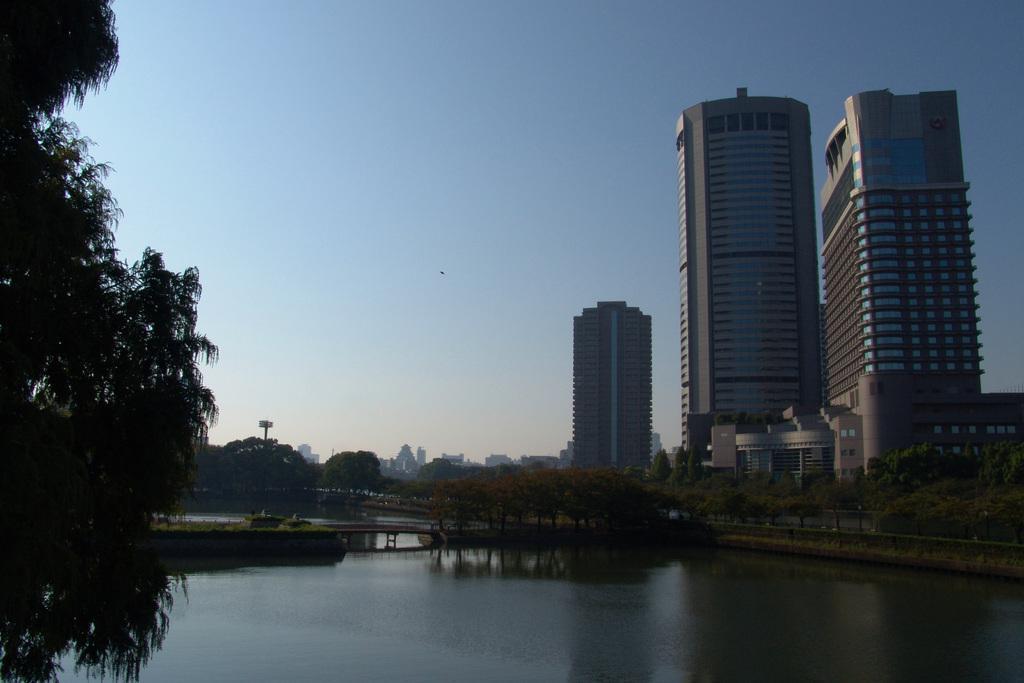Could you give a brief overview of what you see in this image? At the bottom of the image there is water. In the background of the image there are buildings, trees, sky. There is a bridge. To the left side of the image there is a bridge. 